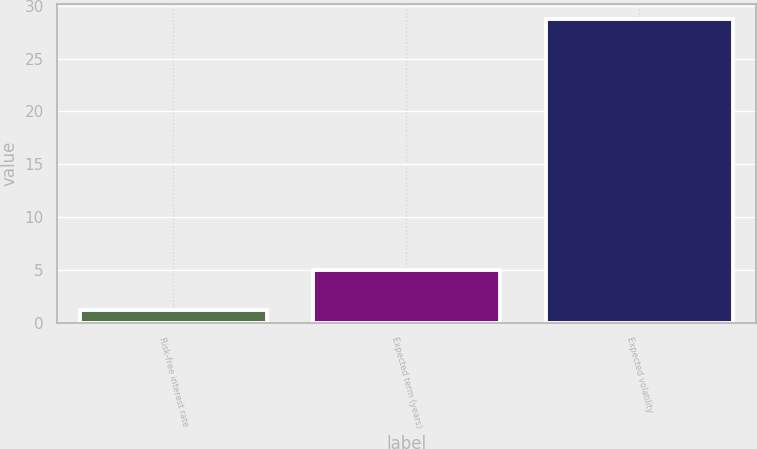<chart> <loc_0><loc_0><loc_500><loc_500><bar_chart><fcel>Risk-free interest rate<fcel>Expected term (years)<fcel>Expected volatility<nl><fcel>1.26<fcel>5<fcel>28.74<nl></chart> 